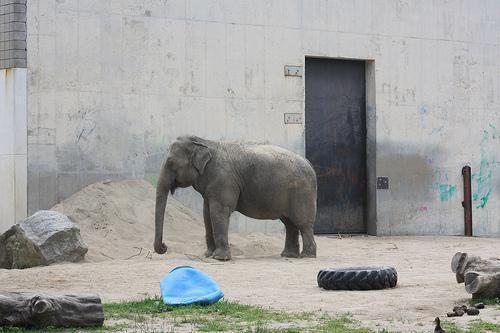How many wheels are there?
Give a very brief answer. 1. 